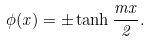<formula> <loc_0><loc_0><loc_500><loc_500>\phi ( x ) = \pm \tanh \frac { m x } { 2 } .</formula> 